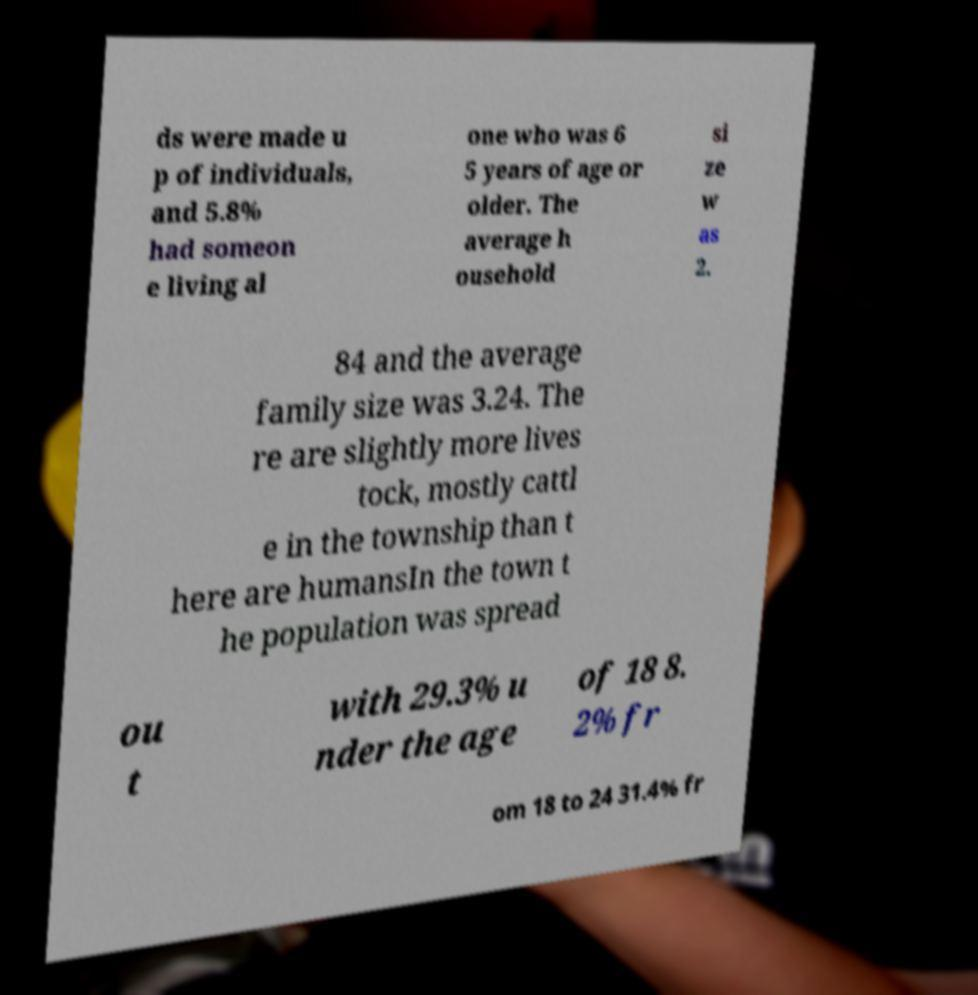Could you assist in decoding the text presented in this image and type it out clearly? ds were made u p of individuals, and 5.8% had someon e living al one who was 6 5 years of age or older. The average h ousehold si ze w as 2. 84 and the average family size was 3.24. The re are slightly more lives tock, mostly cattl e in the township than t here are humansIn the town t he population was spread ou t with 29.3% u nder the age of 18 8. 2% fr om 18 to 24 31.4% fr 